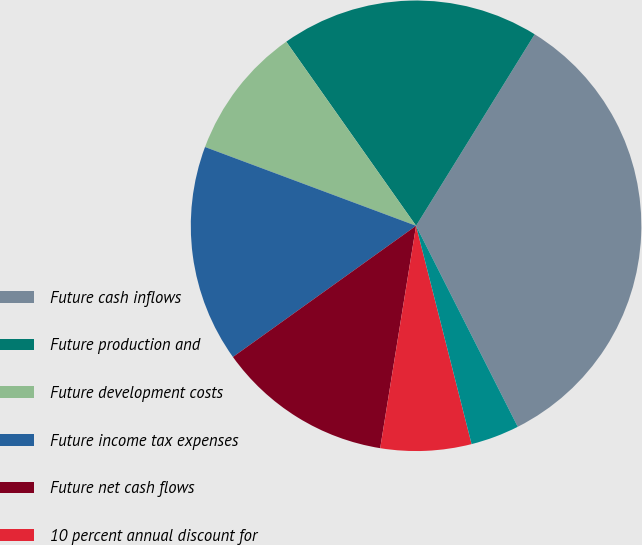Convert chart to OTSL. <chart><loc_0><loc_0><loc_500><loc_500><pie_chart><fcel>Future cash inflows<fcel>Future production and<fcel>Future development costs<fcel>Future income tax expenses<fcel>Future net cash flows<fcel>10 percent annual discount for<fcel>related to continuing<nl><fcel>33.72%<fcel>18.6%<fcel>9.54%<fcel>15.58%<fcel>12.56%<fcel>6.51%<fcel>3.49%<nl></chart> 